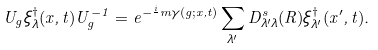Convert formula to latex. <formula><loc_0><loc_0><loc_500><loc_500>U _ { g } \xi _ { \lambda } ^ { \dagger } ( { x } , t ) U ^ { - 1 } _ { g } = e ^ { - \frac { i } { } m \gamma ( g ; { x } , t ) } \sum _ { \lambda ^ { \prime } } D ^ { s } _ { \lambda ^ { \prime } \lambda } ( R ) \xi _ { \lambda ^ { \prime } } ^ { \dagger } ( { x ^ { \prime } } , t ) .</formula> 